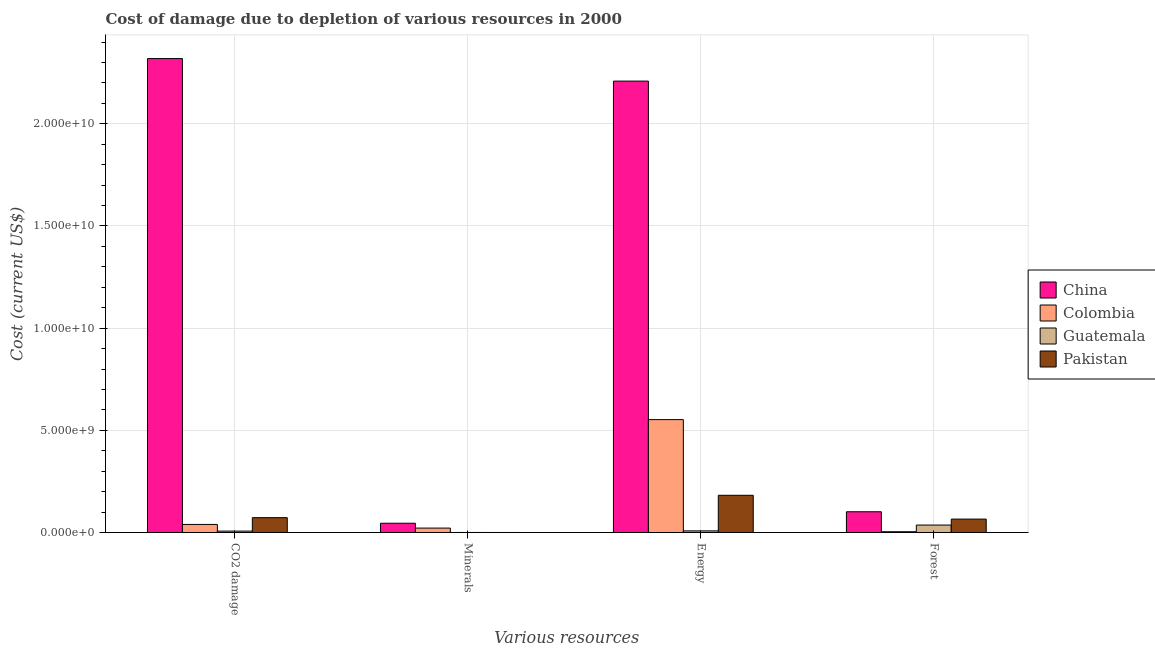How many groups of bars are there?
Provide a short and direct response. 4. Are the number of bars per tick equal to the number of legend labels?
Provide a succinct answer. Yes. How many bars are there on the 2nd tick from the left?
Offer a terse response. 4. How many bars are there on the 4th tick from the right?
Provide a succinct answer. 4. What is the label of the 3rd group of bars from the left?
Ensure brevity in your answer.  Energy. What is the cost of damage due to depletion of forests in Guatemala?
Make the answer very short. 3.64e+08. Across all countries, what is the maximum cost of damage due to depletion of minerals?
Give a very brief answer. 4.53e+08. Across all countries, what is the minimum cost of damage due to depletion of minerals?
Your response must be concise. 5.47e+04. In which country was the cost of damage due to depletion of coal maximum?
Your response must be concise. China. In which country was the cost of damage due to depletion of forests minimum?
Ensure brevity in your answer.  Colombia. What is the total cost of damage due to depletion of forests in the graph?
Your answer should be very brief. 2.07e+09. What is the difference between the cost of damage due to depletion of forests in Pakistan and that in Guatemala?
Give a very brief answer. 2.92e+08. What is the difference between the cost of damage due to depletion of energy in China and the cost of damage due to depletion of coal in Pakistan?
Offer a very short reply. 2.14e+1. What is the average cost of damage due to depletion of forests per country?
Provide a short and direct response. 5.18e+08. What is the difference between the cost of damage due to depletion of coal and cost of damage due to depletion of energy in Colombia?
Offer a very short reply. -5.13e+09. What is the ratio of the cost of damage due to depletion of energy in Guatemala to that in China?
Provide a short and direct response. 0. Is the cost of damage due to depletion of energy in Guatemala less than that in China?
Your response must be concise. Yes. Is the difference between the cost of damage due to depletion of minerals in Colombia and Guatemala greater than the difference between the cost of damage due to depletion of forests in Colombia and Guatemala?
Your response must be concise. Yes. What is the difference between the highest and the second highest cost of damage due to depletion of forests?
Offer a terse response. 3.59e+08. What is the difference between the highest and the lowest cost of damage due to depletion of forests?
Keep it short and to the point. 9.77e+08. In how many countries, is the cost of damage due to depletion of minerals greater than the average cost of damage due to depletion of minerals taken over all countries?
Keep it short and to the point. 2. Is the sum of the cost of damage due to depletion of minerals in China and Colombia greater than the maximum cost of damage due to depletion of coal across all countries?
Provide a short and direct response. No. What does the 2nd bar from the left in Energy represents?
Provide a short and direct response. Colombia. How many countries are there in the graph?
Your answer should be very brief. 4. What is the difference between two consecutive major ticks on the Y-axis?
Make the answer very short. 5.00e+09. Does the graph contain any zero values?
Offer a very short reply. No. Does the graph contain grids?
Provide a short and direct response. Yes. How are the legend labels stacked?
Provide a short and direct response. Vertical. What is the title of the graph?
Give a very brief answer. Cost of damage due to depletion of various resources in 2000 . What is the label or title of the X-axis?
Ensure brevity in your answer.  Various resources. What is the label or title of the Y-axis?
Provide a short and direct response. Cost (current US$). What is the Cost (current US$) of China in CO2 damage?
Keep it short and to the point. 2.32e+1. What is the Cost (current US$) in Colombia in CO2 damage?
Provide a succinct answer. 3.95e+08. What is the Cost (current US$) in Guatemala in CO2 damage?
Ensure brevity in your answer.  6.75e+07. What is the Cost (current US$) of Pakistan in CO2 damage?
Make the answer very short. 7.25e+08. What is the Cost (current US$) in China in Minerals?
Make the answer very short. 4.53e+08. What is the Cost (current US$) of Colombia in Minerals?
Provide a succinct answer. 2.15e+08. What is the Cost (current US$) of Guatemala in Minerals?
Provide a succinct answer. 3.79e+05. What is the Cost (current US$) of Pakistan in Minerals?
Keep it short and to the point. 5.47e+04. What is the Cost (current US$) of China in Energy?
Make the answer very short. 2.21e+1. What is the Cost (current US$) of Colombia in Energy?
Keep it short and to the point. 5.52e+09. What is the Cost (current US$) in Guatemala in Energy?
Give a very brief answer. 7.82e+07. What is the Cost (current US$) in Pakistan in Energy?
Your answer should be very brief. 1.82e+09. What is the Cost (current US$) in China in Forest?
Ensure brevity in your answer.  1.01e+09. What is the Cost (current US$) of Colombia in Forest?
Your response must be concise. 3.74e+07. What is the Cost (current US$) in Guatemala in Forest?
Provide a succinct answer. 3.64e+08. What is the Cost (current US$) of Pakistan in Forest?
Offer a terse response. 6.55e+08. Across all Various resources, what is the maximum Cost (current US$) in China?
Offer a very short reply. 2.32e+1. Across all Various resources, what is the maximum Cost (current US$) of Colombia?
Your answer should be very brief. 5.52e+09. Across all Various resources, what is the maximum Cost (current US$) of Guatemala?
Offer a very short reply. 3.64e+08. Across all Various resources, what is the maximum Cost (current US$) of Pakistan?
Your response must be concise. 1.82e+09. Across all Various resources, what is the minimum Cost (current US$) of China?
Offer a terse response. 4.53e+08. Across all Various resources, what is the minimum Cost (current US$) in Colombia?
Keep it short and to the point. 3.74e+07. Across all Various resources, what is the minimum Cost (current US$) in Guatemala?
Provide a succinct answer. 3.79e+05. Across all Various resources, what is the minimum Cost (current US$) of Pakistan?
Keep it short and to the point. 5.47e+04. What is the total Cost (current US$) of China in the graph?
Your answer should be very brief. 4.67e+1. What is the total Cost (current US$) of Colombia in the graph?
Give a very brief answer. 6.17e+09. What is the total Cost (current US$) in Guatemala in the graph?
Keep it short and to the point. 5.10e+08. What is the total Cost (current US$) in Pakistan in the graph?
Your answer should be compact. 3.20e+09. What is the difference between the Cost (current US$) in China in CO2 damage and that in Minerals?
Your answer should be compact. 2.27e+1. What is the difference between the Cost (current US$) of Colombia in CO2 damage and that in Minerals?
Make the answer very short. 1.80e+08. What is the difference between the Cost (current US$) in Guatemala in CO2 damage and that in Minerals?
Offer a very short reply. 6.72e+07. What is the difference between the Cost (current US$) in Pakistan in CO2 damage and that in Minerals?
Provide a succinct answer. 7.25e+08. What is the difference between the Cost (current US$) in China in CO2 damage and that in Energy?
Offer a very short reply. 1.10e+09. What is the difference between the Cost (current US$) of Colombia in CO2 damage and that in Energy?
Ensure brevity in your answer.  -5.13e+09. What is the difference between the Cost (current US$) of Guatemala in CO2 damage and that in Energy?
Provide a short and direct response. -1.06e+07. What is the difference between the Cost (current US$) of Pakistan in CO2 damage and that in Energy?
Your answer should be compact. -1.10e+09. What is the difference between the Cost (current US$) in China in CO2 damage and that in Forest?
Make the answer very short. 2.22e+1. What is the difference between the Cost (current US$) in Colombia in CO2 damage and that in Forest?
Provide a succinct answer. 3.57e+08. What is the difference between the Cost (current US$) of Guatemala in CO2 damage and that in Forest?
Make the answer very short. -2.96e+08. What is the difference between the Cost (current US$) in Pakistan in CO2 damage and that in Forest?
Provide a succinct answer. 6.97e+07. What is the difference between the Cost (current US$) of China in Minerals and that in Energy?
Your response must be concise. -2.16e+1. What is the difference between the Cost (current US$) in Colombia in Minerals and that in Energy?
Provide a short and direct response. -5.31e+09. What is the difference between the Cost (current US$) of Guatemala in Minerals and that in Energy?
Ensure brevity in your answer.  -7.78e+07. What is the difference between the Cost (current US$) in Pakistan in Minerals and that in Energy?
Give a very brief answer. -1.82e+09. What is the difference between the Cost (current US$) in China in Minerals and that in Forest?
Ensure brevity in your answer.  -5.62e+08. What is the difference between the Cost (current US$) in Colombia in Minerals and that in Forest?
Give a very brief answer. 1.78e+08. What is the difference between the Cost (current US$) in Guatemala in Minerals and that in Forest?
Your answer should be compact. -3.63e+08. What is the difference between the Cost (current US$) of Pakistan in Minerals and that in Forest?
Offer a terse response. -6.55e+08. What is the difference between the Cost (current US$) in China in Energy and that in Forest?
Your answer should be compact. 2.11e+1. What is the difference between the Cost (current US$) of Colombia in Energy and that in Forest?
Make the answer very short. 5.49e+09. What is the difference between the Cost (current US$) in Guatemala in Energy and that in Forest?
Make the answer very short. -2.85e+08. What is the difference between the Cost (current US$) in Pakistan in Energy and that in Forest?
Provide a succinct answer. 1.17e+09. What is the difference between the Cost (current US$) in China in CO2 damage and the Cost (current US$) in Colombia in Minerals?
Give a very brief answer. 2.30e+1. What is the difference between the Cost (current US$) in China in CO2 damage and the Cost (current US$) in Guatemala in Minerals?
Make the answer very short. 2.32e+1. What is the difference between the Cost (current US$) in China in CO2 damage and the Cost (current US$) in Pakistan in Minerals?
Offer a terse response. 2.32e+1. What is the difference between the Cost (current US$) of Colombia in CO2 damage and the Cost (current US$) of Guatemala in Minerals?
Your response must be concise. 3.94e+08. What is the difference between the Cost (current US$) in Colombia in CO2 damage and the Cost (current US$) in Pakistan in Minerals?
Provide a succinct answer. 3.94e+08. What is the difference between the Cost (current US$) of Guatemala in CO2 damage and the Cost (current US$) of Pakistan in Minerals?
Keep it short and to the point. 6.75e+07. What is the difference between the Cost (current US$) of China in CO2 damage and the Cost (current US$) of Colombia in Energy?
Make the answer very short. 1.77e+1. What is the difference between the Cost (current US$) in China in CO2 damage and the Cost (current US$) in Guatemala in Energy?
Give a very brief answer. 2.31e+1. What is the difference between the Cost (current US$) in China in CO2 damage and the Cost (current US$) in Pakistan in Energy?
Give a very brief answer. 2.14e+1. What is the difference between the Cost (current US$) of Colombia in CO2 damage and the Cost (current US$) of Guatemala in Energy?
Your answer should be compact. 3.16e+08. What is the difference between the Cost (current US$) in Colombia in CO2 damage and the Cost (current US$) in Pakistan in Energy?
Ensure brevity in your answer.  -1.43e+09. What is the difference between the Cost (current US$) of Guatemala in CO2 damage and the Cost (current US$) of Pakistan in Energy?
Make the answer very short. -1.75e+09. What is the difference between the Cost (current US$) in China in CO2 damage and the Cost (current US$) in Colombia in Forest?
Provide a short and direct response. 2.32e+1. What is the difference between the Cost (current US$) in China in CO2 damage and the Cost (current US$) in Guatemala in Forest?
Provide a succinct answer. 2.28e+1. What is the difference between the Cost (current US$) of China in CO2 damage and the Cost (current US$) of Pakistan in Forest?
Your answer should be compact. 2.25e+1. What is the difference between the Cost (current US$) in Colombia in CO2 damage and the Cost (current US$) in Guatemala in Forest?
Make the answer very short. 3.09e+07. What is the difference between the Cost (current US$) in Colombia in CO2 damage and the Cost (current US$) in Pakistan in Forest?
Keep it short and to the point. -2.61e+08. What is the difference between the Cost (current US$) in Guatemala in CO2 damage and the Cost (current US$) in Pakistan in Forest?
Give a very brief answer. -5.88e+08. What is the difference between the Cost (current US$) of China in Minerals and the Cost (current US$) of Colombia in Energy?
Give a very brief answer. -5.07e+09. What is the difference between the Cost (current US$) in China in Minerals and the Cost (current US$) in Guatemala in Energy?
Provide a succinct answer. 3.75e+08. What is the difference between the Cost (current US$) in China in Minerals and the Cost (current US$) in Pakistan in Energy?
Your answer should be very brief. -1.37e+09. What is the difference between the Cost (current US$) of Colombia in Minerals and the Cost (current US$) of Guatemala in Energy?
Offer a very short reply. 1.37e+08. What is the difference between the Cost (current US$) in Colombia in Minerals and the Cost (current US$) in Pakistan in Energy?
Your answer should be compact. -1.61e+09. What is the difference between the Cost (current US$) of Guatemala in Minerals and the Cost (current US$) of Pakistan in Energy?
Your answer should be compact. -1.82e+09. What is the difference between the Cost (current US$) of China in Minerals and the Cost (current US$) of Colombia in Forest?
Your answer should be very brief. 4.15e+08. What is the difference between the Cost (current US$) in China in Minerals and the Cost (current US$) in Guatemala in Forest?
Your answer should be very brief. 8.92e+07. What is the difference between the Cost (current US$) of China in Minerals and the Cost (current US$) of Pakistan in Forest?
Offer a very short reply. -2.03e+08. What is the difference between the Cost (current US$) in Colombia in Minerals and the Cost (current US$) in Guatemala in Forest?
Ensure brevity in your answer.  -1.49e+08. What is the difference between the Cost (current US$) of Colombia in Minerals and the Cost (current US$) of Pakistan in Forest?
Provide a succinct answer. -4.40e+08. What is the difference between the Cost (current US$) of Guatemala in Minerals and the Cost (current US$) of Pakistan in Forest?
Provide a succinct answer. -6.55e+08. What is the difference between the Cost (current US$) of China in Energy and the Cost (current US$) of Colombia in Forest?
Keep it short and to the point. 2.21e+1. What is the difference between the Cost (current US$) in China in Energy and the Cost (current US$) in Guatemala in Forest?
Give a very brief answer. 2.17e+1. What is the difference between the Cost (current US$) of China in Energy and the Cost (current US$) of Pakistan in Forest?
Give a very brief answer. 2.14e+1. What is the difference between the Cost (current US$) in Colombia in Energy and the Cost (current US$) in Guatemala in Forest?
Keep it short and to the point. 5.16e+09. What is the difference between the Cost (current US$) in Colombia in Energy and the Cost (current US$) in Pakistan in Forest?
Give a very brief answer. 4.87e+09. What is the difference between the Cost (current US$) in Guatemala in Energy and the Cost (current US$) in Pakistan in Forest?
Make the answer very short. -5.77e+08. What is the average Cost (current US$) of China per Various resources?
Keep it short and to the point. 1.17e+1. What is the average Cost (current US$) in Colombia per Various resources?
Ensure brevity in your answer.  1.54e+09. What is the average Cost (current US$) in Guatemala per Various resources?
Keep it short and to the point. 1.27e+08. What is the average Cost (current US$) in Pakistan per Various resources?
Offer a very short reply. 8.00e+08. What is the difference between the Cost (current US$) of China and Cost (current US$) of Colombia in CO2 damage?
Provide a succinct answer. 2.28e+1. What is the difference between the Cost (current US$) of China and Cost (current US$) of Guatemala in CO2 damage?
Ensure brevity in your answer.  2.31e+1. What is the difference between the Cost (current US$) of China and Cost (current US$) of Pakistan in CO2 damage?
Your response must be concise. 2.25e+1. What is the difference between the Cost (current US$) of Colombia and Cost (current US$) of Guatemala in CO2 damage?
Give a very brief answer. 3.27e+08. What is the difference between the Cost (current US$) in Colombia and Cost (current US$) in Pakistan in CO2 damage?
Give a very brief answer. -3.30e+08. What is the difference between the Cost (current US$) in Guatemala and Cost (current US$) in Pakistan in CO2 damage?
Provide a short and direct response. -6.57e+08. What is the difference between the Cost (current US$) in China and Cost (current US$) in Colombia in Minerals?
Ensure brevity in your answer.  2.38e+08. What is the difference between the Cost (current US$) in China and Cost (current US$) in Guatemala in Minerals?
Ensure brevity in your answer.  4.52e+08. What is the difference between the Cost (current US$) of China and Cost (current US$) of Pakistan in Minerals?
Offer a terse response. 4.53e+08. What is the difference between the Cost (current US$) of Colombia and Cost (current US$) of Guatemala in Minerals?
Your response must be concise. 2.15e+08. What is the difference between the Cost (current US$) of Colombia and Cost (current US$) of Pakistan in Minerals?
Your answer should be compact. 2.15e+08. What is the difference between the Cost (current US$) of Guatemala and Cost (current US$) of Pakistan in Minerals?
Keep it short and to the point. 3.24e+05. What is the difference between the Cost (current US$) in China and Cost (current US$) in Colombia in Energy?
Provide a succinct answer. 1.66e+1. What is the difference between the Cost (current US$) of China and Cost (current US$) of Guatemala in Energy?
Your response must be concise. 2.20e+1. What is the difference between the Cost (current US$) in China and Cost (current US$) in Pakistan in Energy?
Make the answer very short. 2.03e+1. What is the difference between the Cost (current US$) in Colombia and Cost (current US$) in Guatemala in Energy?
Keep it short and to the point. 5.45e+09. What is the difference between the Cost (current US$) in Colombia and Cost (current US$) in Pakistan in Energy?
Ensure brevity in your answer.  3.70e+09. What is the difference between the Cost (current US$) in Guatemala and Cost (current US$) in Pakistan in Energy?
Offer a terse response. -1.74e+09. What is the difference between the Cost (current US$) in China and Cost (current US$) in Colombia in Forest?
Provide a succinct answer. 9.77e+08. What is the difference between the Cost (current US$) in China and Cost (current US$) in Guatemala in Forest?
Provide a short and direct response. 6.51e+08. What is the difference between the Cost (current US$) in China and Cost (current US$) in Pakistan in Forest?
Your answer should be compact. 3.59e+08. What is the difference between the Cost (current US$) in Colombia and Cost (current US$) in Guatemala in Forest?
Offer a very short reply. -3.26e+08. What is the difference between the Cost (current US$) in Colombia and Cost (current US$) in Pakistan in Forest?
Ensure brevity in your answer.  -6.18e+08. What is the difference between the Cost (current US$) of Guatemala and Cost (current US$) of Pakistan in Forest?
Your answer should be very brief. -2.92e+08. What is the ratio of the Cost (current US$) of China in CO2 damage to that in Minerals?
Offer a terse response. 51.22. What is the ratio of the Cost (current US$) of Colombia in CO2 damage to that in Minerals?
Offer a terse response. 1.83. What is the ratio of the Cost (current US$) in Guatemala in CO2 damage to that in Minerals?
Your answer should be very brief. 178.34. What is the ratio of the Cost (current US$) of Pakistan in CO2 damage to that in Minerals?
Offer a terse response. 1.32e+04. What is the ratio of the Cost (current US$) of China in CO2 damage to that in Energy?
Provide a succinct answer. 1.05. What is the ratio of the Cost (current US$) in Colombia in CO2 damage to that in Energy?
Provide a short and direct response. 0.07. What is the ratio of the Cost (current US$) of Guatemala in CO2 damage to that in Energy?
Offer a very short reply. 0.86. What is the ratio of the Cost (current US$) of Pakistan in CO2 damage to that in Energy?
Offer a terse response. 0.4. What is the ratio of the Cost (current US$) of China in CO2 damage to that in Forest?
Give a very brief answer. 22.86. What is the ratio of the Cost (current US$) of Colombia in CO2 damage to that in Forest?
Your answer should be compact. 10.55. What is the ratio of the Cost (current US$) in Guatemala in CO2 damage to that in Forest?
Make the answer very short. 0.19. What is the ratio of the Cost (current US$) of Pakistan in CO2 damage to that in Forest?
Your answer should be compact. 1.11. What is the ratio of the Cost (current US$) in China in Minerals to that in Energy?
Make the answer very short. 0.02. What is the ratio of the Cost (current US$) in Colombia in Minerals to that in Energy?
Offer a very short reply. 0.04. What is the ratio of the Cost (current US$) in Guatemala in Minerals to that in Energy?
Your answer should be compact. 0. What is the ratio of the Cost (current US$) of China in Minerals to that in Forest?
Your answer should be very brief. 0.45. What is the ratio of the Cost (current US$) in Colombia in Minerals to that in Forest?
Provide a succinct answer. 5.75. What is the ratio of the Cost (current US$) of Guatemala in Minerals to that in Forest?
Give a very brief answer. 0. What is the ratio of the Cost (current US$) of China in Energy to that in Forest?
Make the answer very short. 21.78. What is the ratio of the Cost (current US$) of Colombia in Energy to that in Forest?
Make the answer very short. 147.65. What is the ratio of the Cost (current US$) in Guatemala in Energy to that in Forest?
Give a very brief answer. 0.21. What is the ratio of the Cost (current US$) in Pakistan in Energy to that in Forest?
Make the answer very short. 2.78. What is the difference between the highest and the second highest Cost (current US$) of China?
Give a very brief answer. 1.10e+09. What is the difference between the highest and the second highest Cost (current US$) in Colombia?
Your answer should be very brief. 5.13e+09. What is the difference between the highest and the second highest Cost (current US$) of Guatemala?
Keep it short and to the point. 2.85e+08. What is the difference between the highest and the second highest Cost (current US$) in Pakistan?
Give a very brief answer. 1.10e+09. What is the difference between the highest and the lowest Cost (current US$) in China?
Give a very brief answer. 2.27e+1. What is the difference between the highest and the lowest Cost (current US$) in Colombia?
Provide a succinct answer. 5.49e+09. What is the difference between the highest and the lowest Cost (current US$) of Guatemala?
Provide a succinct answer. 3.63e+08. What is the difference between the highest and the lowest Cost (current US$) in Pakistan?
Make the answer very short. 1.82e+09. 